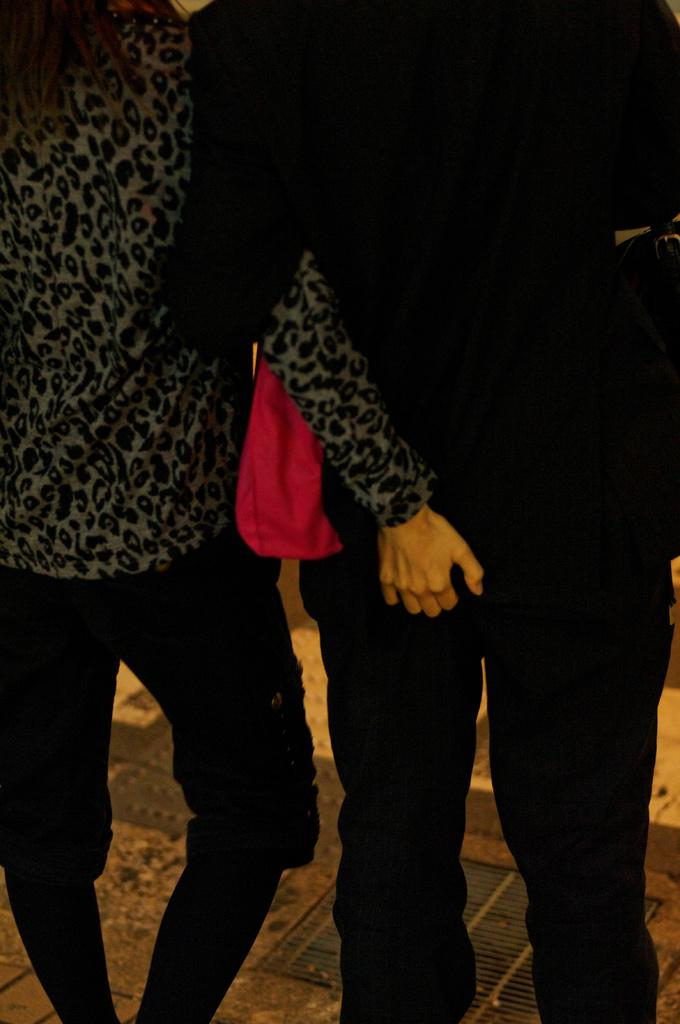How many people are in the image? There are two people in the image. What are the two people doing in the image? The two people are standing and holding each other. What is the surface they are standing on in the image? There is a floor visible in the image. What type of shoes are the people wearing in the image? There is no information about shoes in the image, as it only shows two people standing and holding each other. 